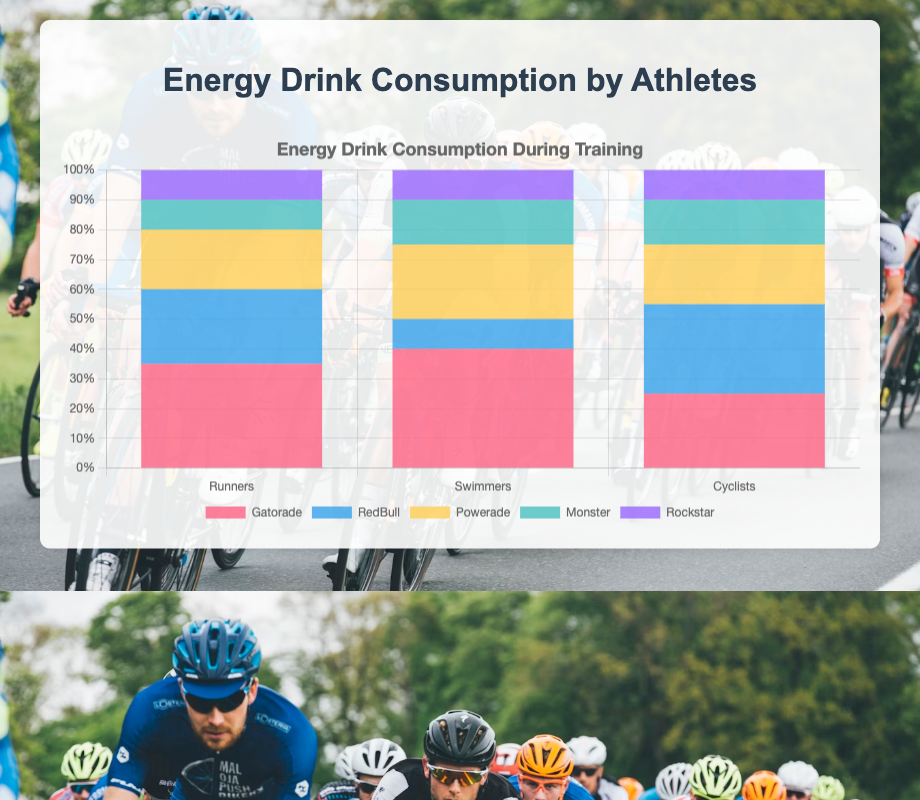What percentage of energy drink consumption for Cyclists comes from RedBull? To find the percentage of energy drink consumption for Cyclists that comes from RedBull, we look at the RedBull consumption for Cyclists which is 30. The total energy drink consumption for Cyclists is the sum of all types, which is (25 + 30 + 20 + 15 + 10) = 100. Thus, the percentage is (30/100) * 100% = 30%.
Answer: 30% Which athlete group has the highest consumption of Gatorade? To determine which athlete group has the highest consumption of Gatorade, we compare the values for each group: Runners (35), Swimmers (40), and Cyclists (25). Swimmers have the highest consumption at 40.
Answer: Swimmers By how much do the runners' consumption of Gatorade exceed their consumption of Monster? The Gatorade consumption for Runners is 35 and the Monster consumption is 10. The difference is 35 - 10 = 25.
Answer: 25 What is the total consumption of Powerade among all athlete groups? To find the total consumption of Powerade among all athlete groups, we add the Powerade values: Runners (20), Swimmers (25), and Cyclists (20). Thus, the total is 20 + 25 + 20 = 65.
Answer: 65 Which energy drink is consumed equally by all types of athletes? By examining the values, Rockstar consumption is 10 for each group (Runners, Swimmers, Cyclists).
Answer: Rockstar Compare the total consumption of Gatorade and RedBull among all athletes. Which one is higher? First, calculate the total Gatorade consumption: 35 (Runners) + 40 (Swimmers) + 25 (Cyclists) = 100. Next, calculate the total RedBull consumption: 25 (Runners) + 10 (Swimmers) + 30 (Cyclists) = 65. Gatorade has a higher total consumption.
Answer: Gatorade Which two athlete types have the same consumption for Monster? By looking at the values, both Swimmers and Cyclists have a Monster consumption of 15.
Answer: Swimmers and Cyclists What is the average consumption of RedBull across all athlete types? The total consumption of RedBull is: 25 (Runners) + 10 (Swimmers) + 30 (Cyclists) = 65. There are 3 athlete types, so the average is 65 / 3 ≈ 21.67.
Answer: 21.67 If you sum up the energy drink consumption of Runners for Gatorade and Rockstar together, what is the total? The Gatorade consumption for Runners is 35 and Rockstar is 10. The sum is 35 + 10 = 45.
Answer: 45 